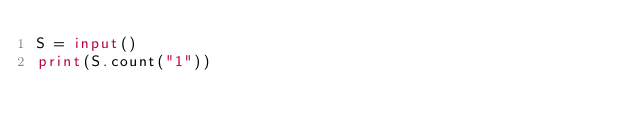<code> <loc_0><loc_0><loc_500><loc_500><_Python_>S = input()
print(S.count("1"))</code> 